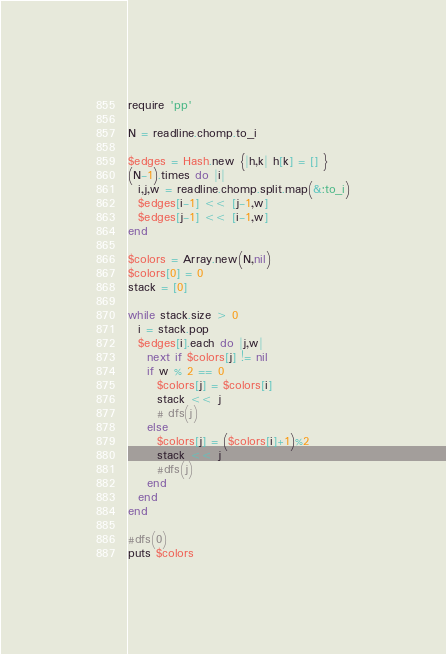Convert code to text. <code><loc_0><loc_0><loc_500><loc_500><_Ruby_>require 'pp'

N = readline.chomp.to_i

$edges = Hash.new {|h,k| h[k] = [] }
(N-1).times do |i|
  i,j,w = readline.chomp.split.map(&:to_i)
  $edges[i-1] << [j-1,w]
  $edges[j-1] << [i-1,w]
end

$colors = Array.new(N,nil)
$colors[0] = 0
stack = [0]

while stack.size > 0
  i = stack.pop
  $edges[i].each do |j,w|
    next if $colors[j] != nil
    if w % 2 == 0
      $colors[j] = $colors[i]
      stack << j
      # dfs(j)
    else
      $colors[j] = ($colors[i]+1)%2
      stack << j
      #dfs(j)
    end
  end
end

#dfs(0)
puts $colors
</code> 